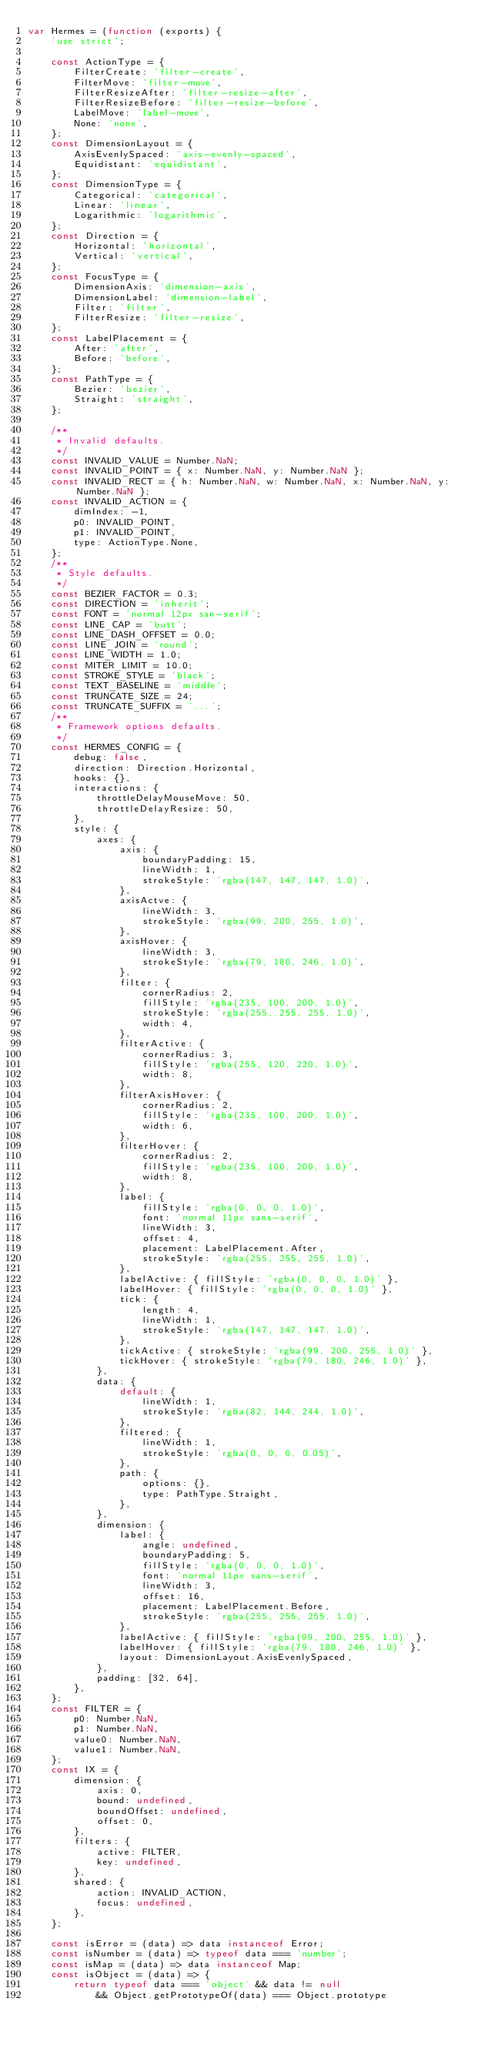Convert code to text. <code><loc_0><loc_0><loc_500><loc_500><_JavaScript_>var Hermes = (function (exports) {
    'use strict';

    const ActionType = {
        FilterCreate: 'filter-create',
        FilterMove: 'filter-move',
        FilterResizeAfter: 'filter-resize-after',
        FilterResizeBefore: 'filter-resize-before',
        LabelMove: 'label-move',
        None: 'none',
    };
    const DimensionLayout = {
        AxisEvenlySpaced: 'axis-evenly-spaced',
        Equidistant: 'equidistant',
    };
    const DimensionType = {
        Categorical: 'categorical',
        Linear: 'linear',
        Logarithmic: 'logarithmic',
    };
    const Direction = {
        Horizontal: 'horizontal',
        Vertical: 'vertical',
    };
    const FocusType = {
        DimensionAxis: 'dimension-axis',
        DimensionLabel: 'dimension-label',
        Filter: 'filter',
        FilterResize: 'filter-resize',
    };
    const LabelPlacement = {
        After: 'after',
        Before: 'before',
    };
    const PathType = {
        Bezier: 'bezier',
        Straight: 'straight',
    };

    /**
     * Invalid defaults.
     */
    const INVALID_VALUE = Number.NaN;
    const INVALID_POINT = { x: Number.NaN, y: Number.NaN };
    const INVALID_RECT = { h: Number.NaN, w: Number.NaN, x: Number.NaN, y: Number.NaN };
    const INVALID_ACTION = {
        dimIndex: -1,
        p0: INVALID_POINT,
        p1: INVALID_POINT,
        type: ActionType.None,
    };
    /**
     * Style defaults.
     */
    const BEZIER_FACTOR = 0.3;
    const DIRECTION = 'inherit';
    const FONT = 'normal 12px san-serif';
    const LINE_CAP = 'butt';
    const LINE_DASH_OFFSET = 0.0;
    const LINE_JOIN = 'round';
    const LINE_WIDTH = 1.0;
    const MITER_LIMIT = 10.0;
    const STROKE_STYLE = 'black';
    const TEXT_BASELINE = 'middle';
    const TRUNCATE_SIZE = 24;
    const TRUNCATE_SUFFIX = '...';
    /**
     * Framework options defaults.
     */
    const HERMES_CONFIG = {
        debug: false,
        direction: Direction.Horizontal,
        hooks: {},
        interactions: {
            throttleDelayMouseMove: 50,
            throttleDelayResize: 50,
        },
        style: {
            axes: {
                axis: {
                    boundaryPadding: 15,
                    lineWidth: 1,
                    strokeStyle: 'rgba(147, 147, 147, 1.0)',
                },
                axisActve: {
                    lineWidth: 3,
                    strokeStyle: 'rgba(99, 200, 255, 1.0)',
                },
                axisHover: {
                    lineWidth: 3,
                    strokeStyle: 'rgba(79, 180, 246, 1.0)',
                },
                filter: {
                    cornerRadius: 2,
                    fillStyle: 'rgba(235, 100, 200, 1.0)',
                    strokeStyle: 'rgba(255, 255, 255, 1.0)',
                    width: 4,
                },
                filterActive: {
                    cornerRadius: 3,
                    fillStyle: 'rgba(255, 120, 220, 1.0)',
                    width: 8,
                },
                filterAxisHover: {
                    cornerRadius: 2,
                    fillStyle: 'rgba(235, 100, 200, 1.0)',
                    width: 6,
                },
                filterHover: {
                    cornerRadius: 2,
                    fillStyle: 'rgba(235, 100, 200, 1.0)',
                    width: 8,
                },
                label: {
                    fillStyle: 'rgba(0, 0, 0, 1.0)',
                    font: 'normal 11px sans-serif',
                    lineWidth: 3,
                    offset: 4,
                    placement: LabelPlacement.After,
                    strokeStyle: 'rgba(255, 255, 255, 1.0)',
                },
                labelActive: { fillStyle: 'rgba(0, 0, 0, 1.0)' },
                labelHover: { fillStyle: 'rgba(0, 0, 0, 1.0)' },
                tick: {
                    length: 4,
                    lineWidth: 1,
                    strokeStyle: 'rgba(147, 147, 147, 1.0)',
                },
                tickActive: { strokeStyle: 'rgba(99, 200, 255, 1.0)' },
                tickHover: { strokeStyle: 'rgba(79, 180, 246, 1.0)' },
            },
            data: {
                default: {
                    lineWidth: 1,
                    strokeStyle: 'rgba(82, 144, 244, 1.0)',
                },
                filtered: {
                    lineWidth: 1,
                    strokeStyle: 'rgba(0, 0, 0, 0.05)',
                },
                path: {
                    options: {},
                    type: PathType.Straight,
                },
            },
            dimension: {
                label: {
                    angle: undefined,
                    boundaryPadding: 5,
                    fillStyle: 'rgba(0, 0, 0, 1.0)',
                    font: 'normal 11px sans-serif',
                    lineWidth: 3,
                    offset: 16,
                    placement: LabelPlacement.Before,
                    strokeStyle: 'rgba(255, 255, 255, 1.0)',
                },
                labelActive: { fillStyle: 'rgba(99, 200, 255, 1.0)' },
                labelHover: { fillStyle: 'rgba(79, 180, 246, 1.0)' },
                layout: DimensionLayout.AxisEvenlySpaced,
            },
            padding: [32, 64],
        },
    };
    const FILTER = {
        p0: Number.NaN,
        p1: Number.NaN,
        value0: Number.NaN,
        value1: Number.NaN,
    };
    const IX = {
        dimension: {
            axis: 0,
            bound: undefined,
            boundOffset: undefined,
            offset: 0,
        },
        filters: {
            active: FILTER,
            key: undefined,
        },
        shared: {
            action: INVALID_ACTION,
            focus: undefined,
        },
    };

    const isError = (data) => data instanceof Error;
    const isNumber = (data) => typeof data === 'number';
    const isMap = (data) => data instanceof Map;
    const isObject = (data) => {
        return typeof data === 'object' && data != null
            && Object.getPrototypeOf(data) === Object.prototype</code> 